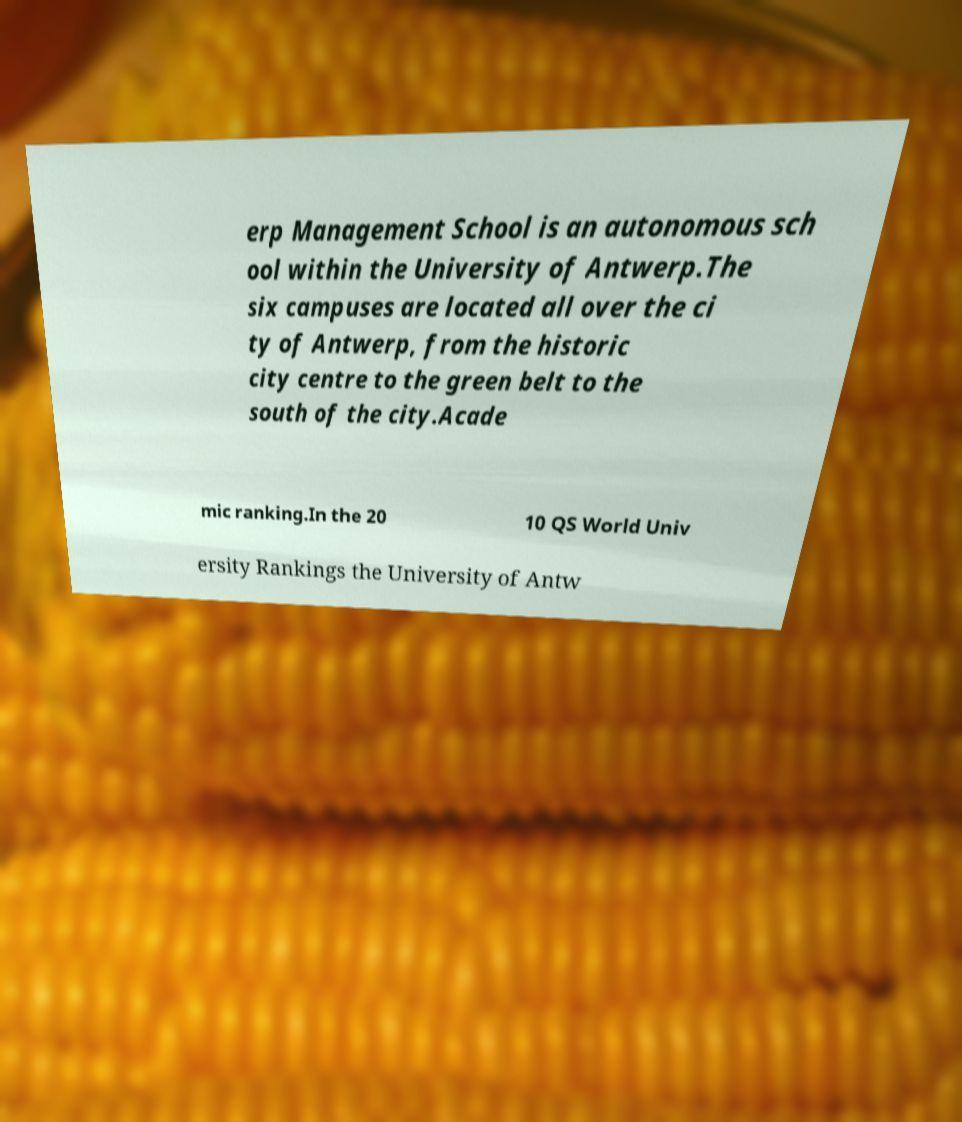What messages or text are displayed in this image? I need them in a readable, typed format. erp Management School is an autonomous sch ool within the University of Antwerp.The six campuses are located all over the ci ty of Antwerp, from the historic city centre to the green belt to the south of the city.Acade mic ranking.In the 20 10 QS World Univ ersity Rankings the University of Antw 